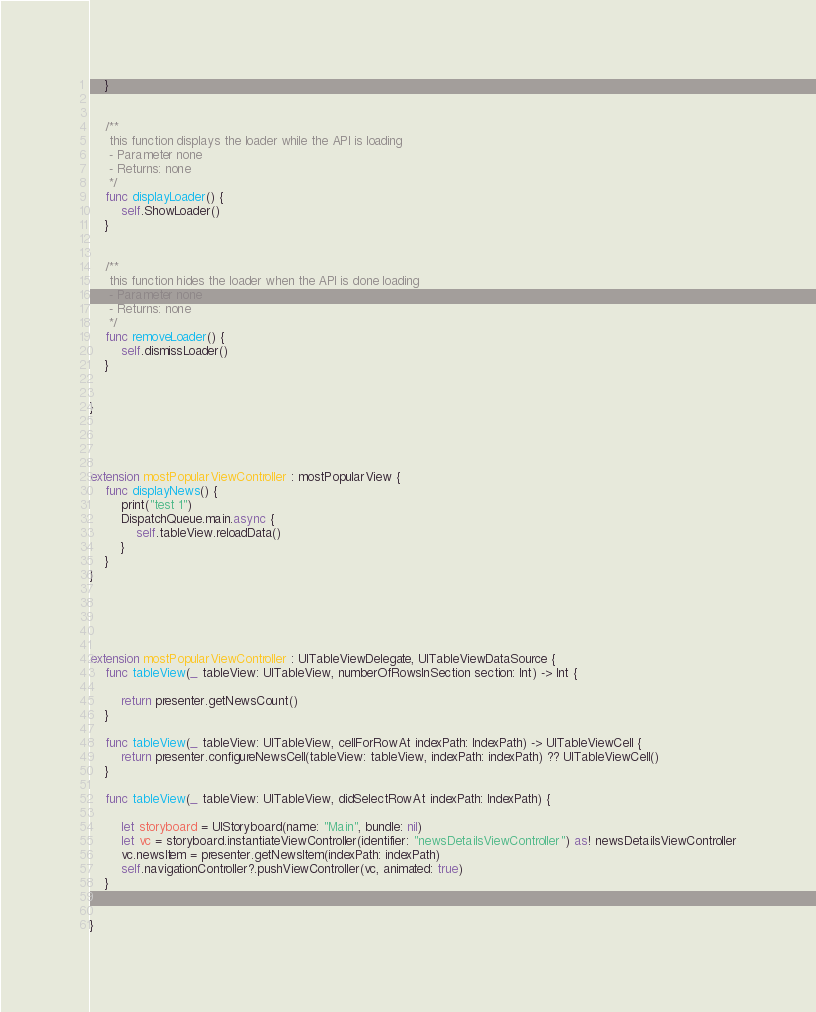<code> <loc_0><loc_0><loc_500><loc_500><_Swift_>    }
    
    
    /**
     this function displays the loader while the API is loading
     - Parameter none
     - Returns: none
     */
    func displayLoader() {
        self.ShowLoader()
    }
    
    
    /**
     this function hides the loader when the API is done loading
     - Parameter none
     - Returns: none
     */
    func removeLoader() {
        self.dismissLoader()
    }
    
    
}




extension mostPopularViewController : mostPopularView {
    func displayNews() {
        print("test 1")
        DispatchQueue.main.async {
            self.tableView.reloadData()
        }
    }
}





extension mostPopularViewController : UITableViewDelegate, UITableViewDataSource {
    func tableView(_ tableView: UITableView, numberOfRowsInSection section: Int) -> Int {
        
        return presenter.getNewsCount()
    }
    
    func tableView(_ tableView: UITableView, cellForRowAt indexPath: IndexPath) -> UITableViewCell {
        return presenter.configureNewsCell(tableView: tableView, indexPath: indexPath) ?? UITableViewCell()
    }
    
    func tableView(_ tableView: UITableView, didSelectRowAt indexPath: IndexPath) {
        
        let storyboard = UIStoryboard(name: "Main", bundle: nil)
        let vc = storyboard.instantiateViewController(identifier: "newsDetailsViewController") as! newsDetailsViewController
        vc.newsItem = presenter.getNewsItem(indexPath: indexPath)
        self.navigationController?.pushViewController(vc, animated: true)
    }
    
    
}
</code> 